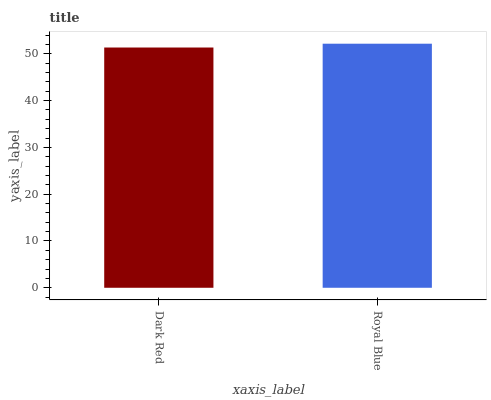Is Dark Red the minimum?
Answer yes or no. Yes. Is Royal Blue the maximum?
Answer yes or no. Yes. Is Royal Blue the minimum?
Answer yes or no. No. Is Royal Blue greater than Dark Red?
Answer yes or no. Yes. Is Dark Red less than Royal Blue?
Answer yes or no. Yes. Is Dark Red greater than Royal Blue?
Answer yes or no. No. Is Royal Blue less than Dark Red?
Answer yes or no. No. Is Royal Blue the high median?
Answer yes or no. Yes. Is Dark Red the low median?
Answer yes or no. Yes. Is Dark Red the high median?
Answer yes or no. No. Is Royal Blue the low median?
Answer yes or no. No. 